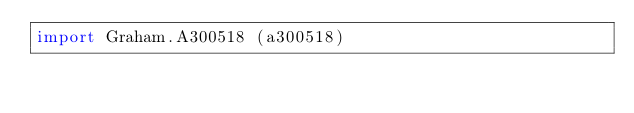Convert code to text. <code><loc_0><loc_0><loc_500><loc_500><_Haskell_>import Graham.A300518 (a300518)</code> 